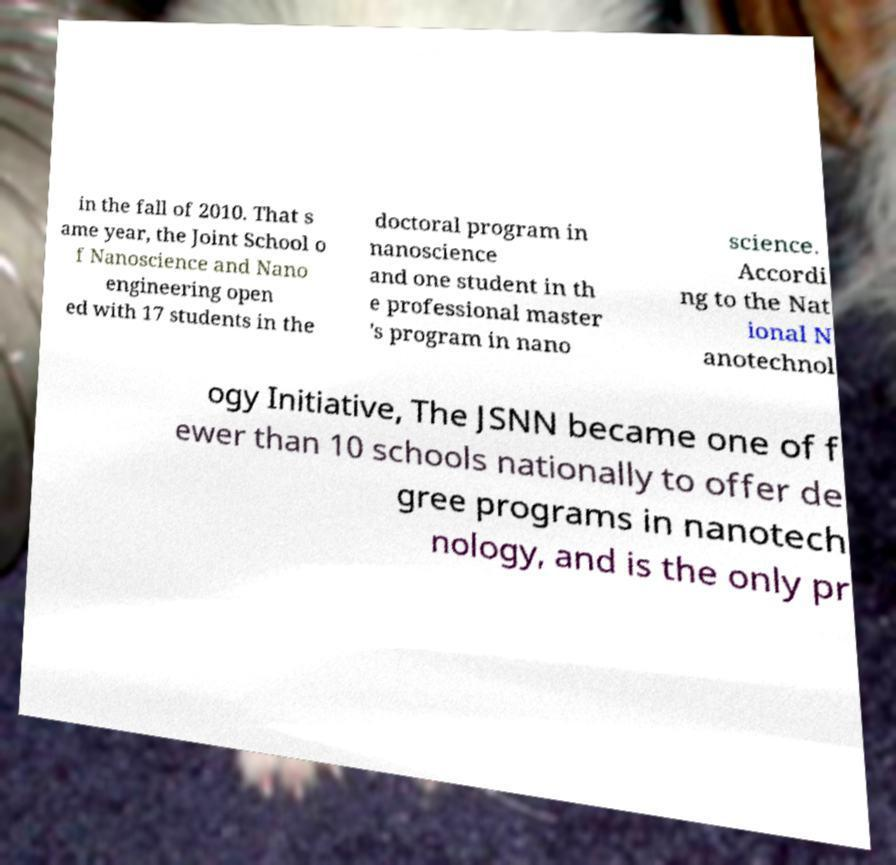What messages or text are displayed in this image? I need them in a readable, typed format. in the fall of 2010. That s ame year, the Joint School o f Nanoscience and Nano engineering open ed with 17 students in the doctoral program in nanoscience and one student in th e professional master 's program in nano science. Accordi ng to the Nat ional N anotechnol ogy Initiative, The JSNN became one of f ewer than 10 schools nationally to offer de gree programs in nanotech nology, and is the only pr 